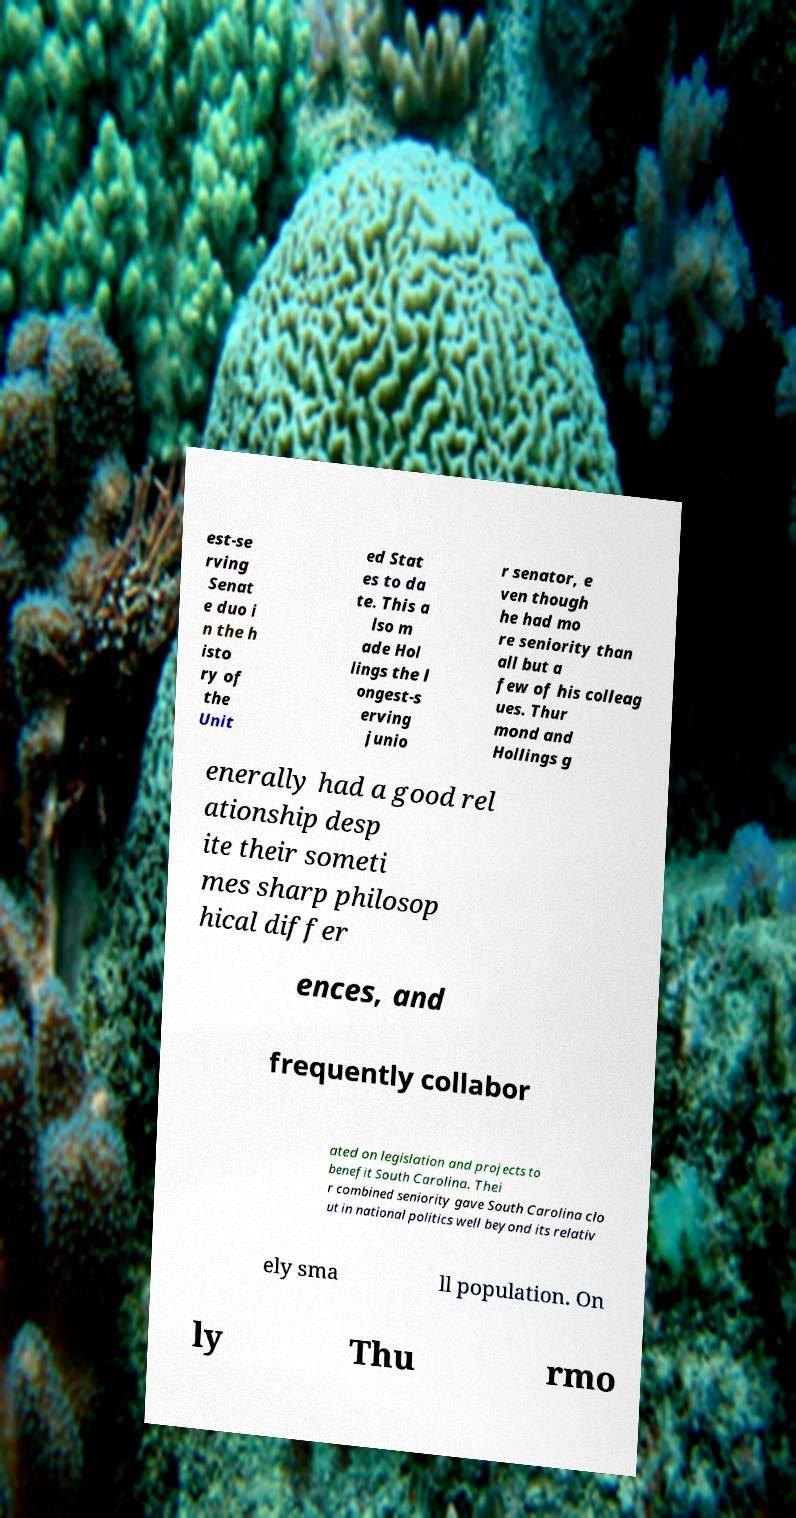Please read and relay the text visible in this image. What does it say? est-se rving Senat e duo i n the h isto ry of the Unit ed Stat es to da te. This a lso m ade Hol lings the l ongest-s erving junio r senator, e ven though he had mo re seniority than all but a few of his colleag ues. Thur mond and Hollings g enerally had a good rel ationship desp ite their someti mes sharp philosop hical differ ences, and frequently collabor ated on legislation and projects to benefit South Carolina. Thei r combined seniority gave South Carolina clo ut in national politics well beyond its relativ ely sma ll population. On ly Thu rmo 